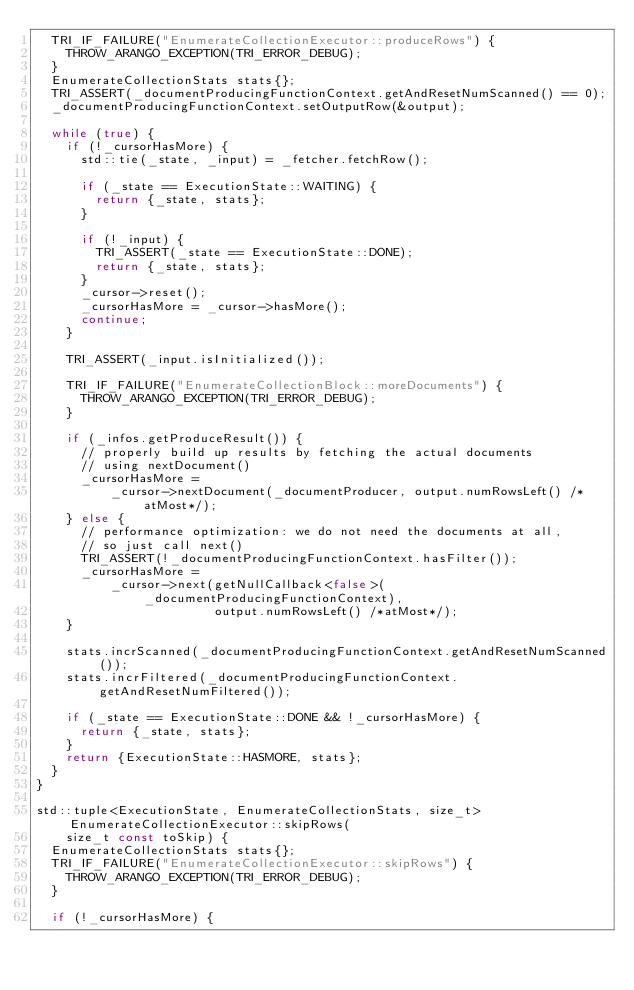Convert code to text. <code><loc_0><loc_0><loc_500><loc_500><_C++_>  TRI_IF_FAILURE("EnumerateCollectionExecutor::produceRows") {
    THROW_ARANGO_EXCEPTION(TRI_ERROR_DEBUG);
  }
  EnumerateCollectionStats stats{};
  TRI_ASSERT(_documentProducingFunctionContext.getAndResetNumScanned() == 0);
  _documentProducingFunctionContext.setOutputRow(&output);

  while (true) {
    if (!_cursorHasMore) {
      std::tie(_state, _input) = _fetcher.fetchRow();

      if (_state == ExecutionState::WAITING) {
        return {_state, stats};
      }

      if (!_input) {
        TRI_ASSERT(_state == ExecutionState::DONE);
        return {_state, stats};
      }
      _cursor->reset();
      _cursorHasMore = _cursor->hasMore();
      continue;
    }

    TRI_ASSERT(_input.isInitialized());

    TRI_IF_FAILURE("EnumerateCollectionBlock::moreDocuments") {
      THROW_ARANGO_EXCEPTION(TRI_ERROR_DEBUG);
    }

    if (_infos.getProduceResult()) {
      // properly build up results by fetching the actual documents
      // using nextDocument()
      _cursorHasMore =
          _cursor->nextDocument(_documentProducer, output.numRowsLeft() /*atMost*/);
    } else {
      // performance optimization: we do not need the documents at all,
      // so just call next()
      TRI_ASSERT(!_documentProducingFunctionContext.hasFilter());
      _cursorHasMore =
          _cursor->next(getNullCallback<false>(_documentProducingFunctionContext),
                        output.numRowsLeft() /*atMost*/);
    }

    stats.incrScanned(_documentProducingFunctionContext.getAndResetNumScanned());
    stats.incrFiltered(_documentProducingFunctionContext.getAndResetNumFiltered());

    if (_state == ExecutionState::DONE && !_cursorHasMore) {
      return {_state, stats};
    }
    return {ExecutionState::HASMORE, stats};
  }
}

std::tuple<ExecutionState, EnumerateCollectionStats, size_t> EnumerateCollectionExecutor::skipRows(
    size_t const toSkip) {
  EnumerateCollectionStats stats{};
  TRI_IF_FAILURE("EnumerateCollectionExecutor::skipRows") {
    THROW_ARANGO_EXCEPTION(TRI_ERROR_DEBUG);
  }

  if (!_cursorHasMore) {</code> 